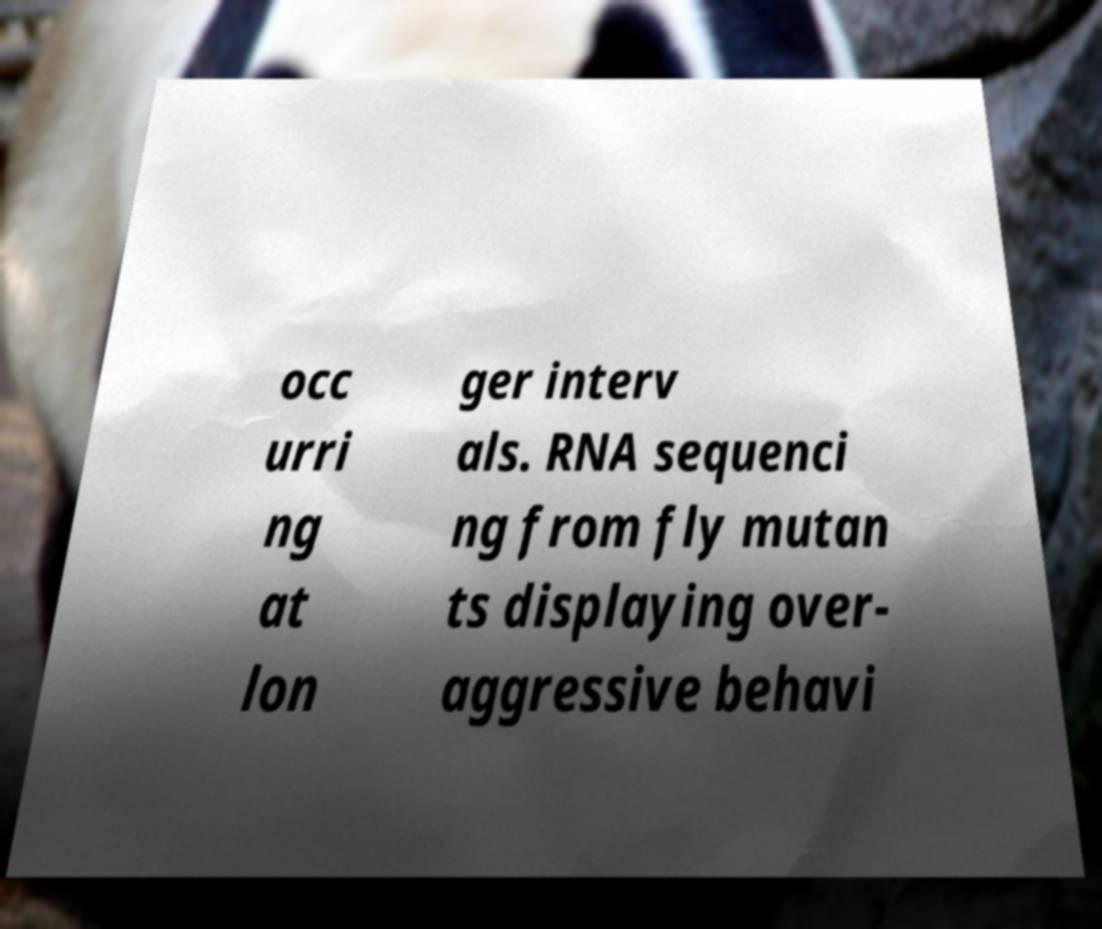Please identify and transcribe the text found in this image. occ urri ng at lon ger interv als. RNA sequenci ng from fly mutan ts displaying over- aggressive behavi 